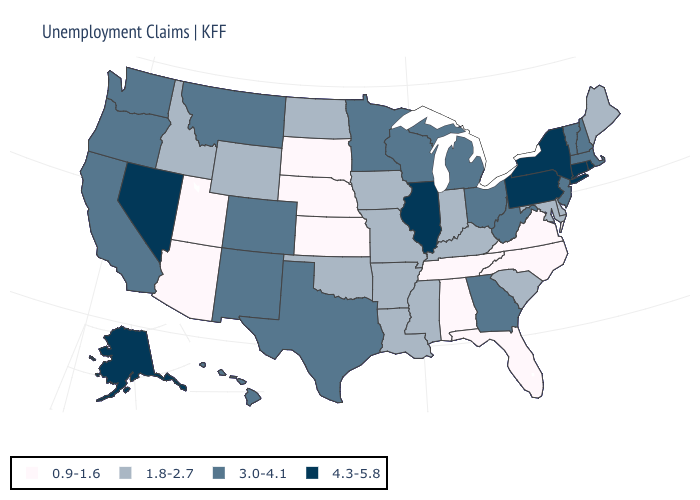Name the states that have a value in the range 1.8-2.7?
Answer briefly. Arkansas, Delaware, Idaho, Indiana, Iowa, Kentucky, Louisiana, Maine, Maryland, Mississippi, Missouri, North Dakota, Oklahoma, South Carolina, Wyoming. Name the states that have a value in the range 3.0-4.1?
Be succinct. California, Colorado, Georgia, Hawaii, Massachusetts, Michigan, Minnesota, Montana, New Hampshire, New Jersey, New Mexico, Ohio, Oregon, Texas, Vermont, Washington, West Virginia, Wisconsin. Which states have the lowest value in the USA?
Concise answer only. Alabama, Arizona, Florida, Kansas, Nebraska, North Carolina, South Dakota, Tennessee, Utah, Virginia. Name the states that have a value in the range 3.0-4.1?
Give a very brief answer. California, Colorado, Georgia, Hawaii, Massachusetts, Michigan, Minnesota, Montana, New Hampshire, New Jersey, New Mexico, Ohio, Oregon, Texas, Vermont, Washington, West Virginia, Wisconsin. What is the value of Kansas?
Keep it brief. 0.9-1.6. Does the map have missing data?
Answer briefly. No. What is the value of Idaho?
Write a very short answer. 1.8-2.7. Name the states that have a value in the range 3.0-4.1?
Be succinct. California, Colorado, Georgia, Hawaii, Massachusetts, Michigan, Minnesota, Montana, New Hampshire, New Jersey, New Mexico, Ohio, Oregon, Texas, Vermont, Washington, West Virginia, Wisconsin. What is the value of Michigan?
Answer briefly. 3.0-4.1. Among the states that border Vermont , which have the highest value?
Write a very short answer. New York. Does Oregon have a higher value than Oklahoma?
Quick response, please. Yes. What is the lowest value in states that border Massachusetts?
Concise answer only. 3.0-4.1. Which states hav the highest value in the MidWest?
Answer briefly. Illinois. What is the lowest value in states that border Oregon?
Answer briefly. 1.8-2.7. 